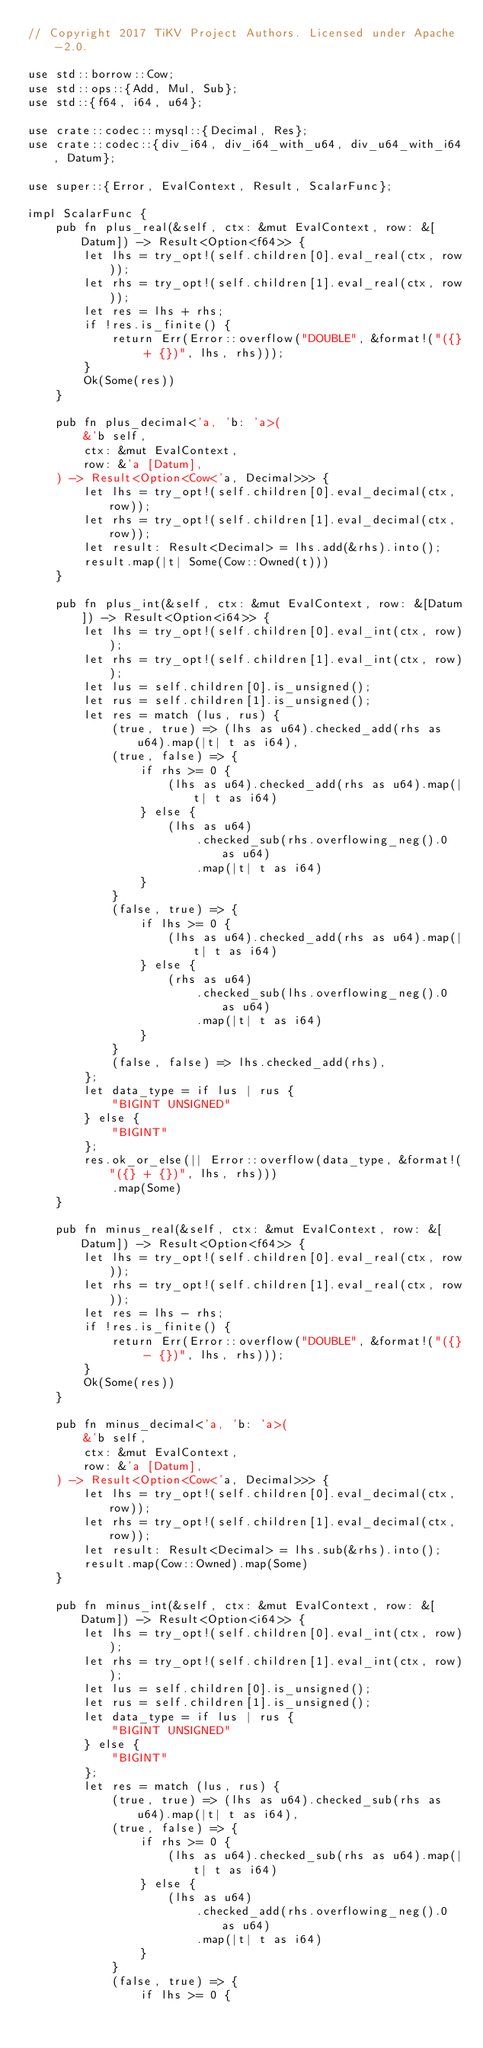<code> <loc_0><loc_0><loc_500><loc_500><_Rust_>// Copyright 2017 TiKV Project Authors. Licensed under Apache-2.0.

use std::borrow::Cow;
use std::ops::{Add, Mul, Sub};
use std::{f64, i64, u64};

use crate::codec::mysql::{Decimal, Res};
use crate::codec::{div_i64, div_i64_with_u64, div_u64_with_i64, Datum};

use super::{Error, EvalContext, Result, ScalarFunc};

impl ScalarFunc {
    pub fn plus_real(&self, ctx: &mut EvalContext, row: &[Datum]) -> Result<Option<f64>> {
        let lhs = try_opt!(self.children[0].eval_real(ctx, row));
        let rhs = try_opt!(self.children[1].eval_real(ctx, row));
        let res = lhs + rhs;
        if !res.is_finite() {
            return Err(Error::overflow("DOUBLE", &format!("({} + {})", lhs, rhs)));
        }
        Ok(Some(res))
    }

    pub fn plus_decimal<'a, 'b: 'a>(
        &'b self,
        ctx: &mut EvalContext,
        row: &'a [Datum],
    ) -> Result<Option<Cow<'a, Decimal>>> {
        let lhs = try_opt!(self.children[0].eval_decimal(ctx, row));
        let rhs = try_opt!(self.children[1].eval_decimal(ctx, row));
        let result: Result<Decimal> = lhs.add(&rhs).into();
        result.map(|t| Some(Cow::Owned(t)))
    }

    pub fn plus_int(&self, ctx: &mut EvalContext, row: &[Datum]) -> Result<Option<i64>> {
        let lhs = try_opt!(self.children[0].eval_int(ctx, row));
        let rhs = try_opt!(self.children[1].eval_int(ctx, row));
        let lus = self.children[0].is_unsigned();
        let rus = self.children[1].is_unsigned();
        let res = match (lus, rus) {
            (true, true) => (lhs as u64).checked_add(rhs as u64).map(|t| t as i64),
            (true, false) => {
                if rhs >= 0 {
                    (lhs as u64).checked_add(rhs as u64).map(|t| t as i64)
                } else {
                    (lhs as u64)
                        .checked_sub(rhs.overflowing_neg().0 as u64)
                        .map(|t| t as i64)
                }
            }
            (false, true) => {
                if lhs >= 0 {
                    (lhs as u64).checked_add(rhs as u64).map(|t| t as i64)
                } else {
                    (rhs as u64)
                        .checked_sub(lhs.overflowing_neg().0 as u64)
                        .map(|t| t as i64)
                }
            }
            (false, false) => lhs.checked_add(rhs),
        };
        let data_type = if lus | rus {
            "BIGINT UNSIGNED"
        } else {
            "BIGINT"
        };
        res.ok_or_else(|| Error::overflow(data_type, &format!("({} + {})", lhs, rhs)))
            .map(Some)
    }

    pub fn minus_real(&self, ctx: &mut EvalContext, row: &[Datum]) -> Result<Option<f64>> {
        let lhs = try_opt!(self.children[0].eval_real(ctx, row));
        let rhs = try_opt!(self.children[1].eval_real(ctx, row));
        let res = lhs - rhs;
        if !res.is_finite() {
            return Err(Error::overflow("DOUBLE", &format!("({} - {})", lhs, rhs)));
        }
        Ok(Some(res))
    }

    pub fn minus_decimal<'a, 'b: 'a>(
        &'b self,
        ctx: &mut EvalContext,
        row: &'a [Datum],
    ) -> Result<Option<Cow<'a, Decimal>>> {
        let lhs = try_opt!(self.children[0].eval_decimal(ctx, row));
        let rhs = try_opt!(self.children[1].eval_decimal(ctx, row));
        let result: Result<Decimal> = lhs.sub(&rhs).into();
        result.map(Cow::Owned).map(Some)
    }

    pub fn minus_int(&self, ctx: &mut EvalContext, row: &[Datum]) -> Result<Option<i64>> {
        let lhs = try_opt!(self.children[0].eval_int(ctx, row));
        let rhs = try_opt!(self.children[1].eval_int(ctx, row));
        let lus = self.children[0].is_unsigned();
        let rus = self.children[1].is_unsigned();
        let data_type = if lus | rus {
            "BIGINT UNSIGNED"
        } else {
            "BIGINT"
        };
        let res = match (lus, rus) {
            (true, true) => (lhs as u64).checked_sub(rhs as u64).map(|t| t as i64),
            (true, false) => {
                if rhs >= 0 {
                    (lhs as u64).checked_sub(rhs as u64).map(|t| t as i64)
                } else {
                    (lhs as u64)
                        .checked_add(rhs.overflowing_neg().0 as u64)
                        .map(|t| t as i64)
                }
            }
            (false, true) => {
                if lhs >= 0 {</code> 